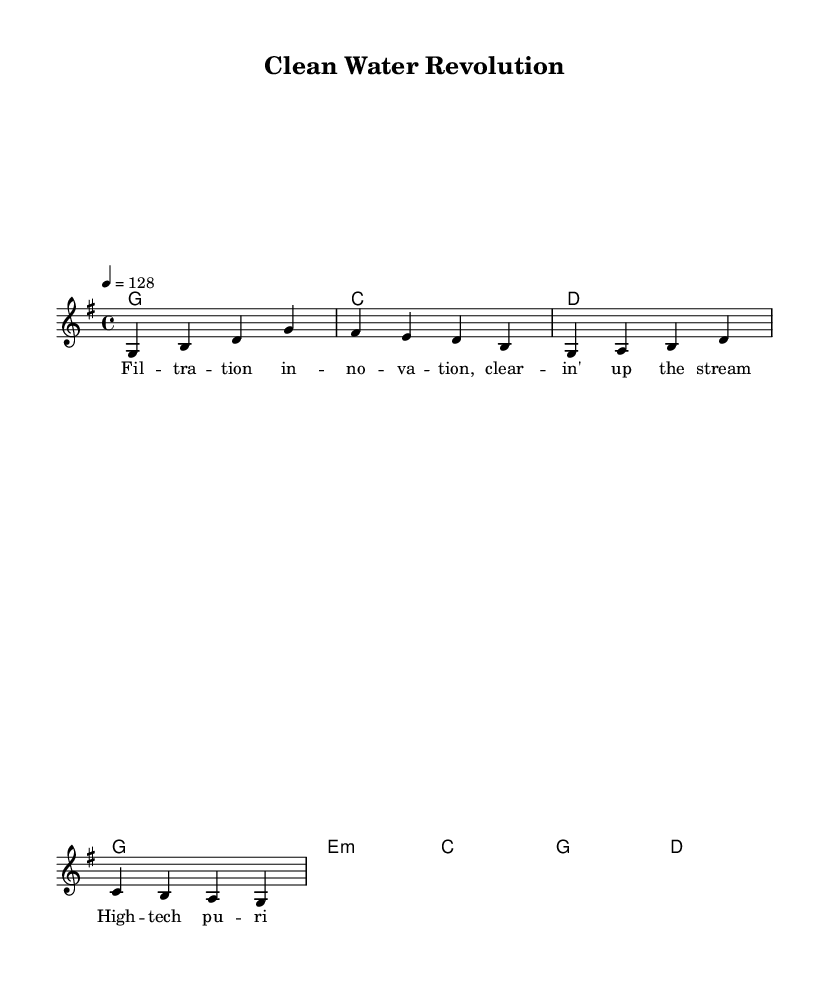What is the key signature of this music? The key signature is G major, which has one sharp (F#) indicated by the "g" shown at the beginning of the global section.
Answer: G major What is the time signature of this music? The time signature is 4/4, which is indicated at the beginning of the global section where "4/4" is mentioned.
Answer: 4/4 What is the tempo marking of this piece? The tempo marking is 128 beats per minute, indicated by the "4 = 128" notation in the tempo section.
Answer: 128 How many bars are in the melody section? There are eight bars in the melody section, as counted by the number of measures in the melody part of the score.
Answer: Eight What is the first word of the lyrics? The first word of the lyrics is "Filtration," as seen in the lyrics section under verseWords.
Answer: Filtration What major chord is established in the harmonies section? The harmonies establish a G major chord first, which is indicated by the G symbol followed by the first measure.
Answer: G What themes does this music reflect specific to Country Rock? This music reflects themes of technological innovation in water treatment, celebrating advancements as seen in the lyrics and upbeat style typical of Country Rock.
Answer: Technological innovation 